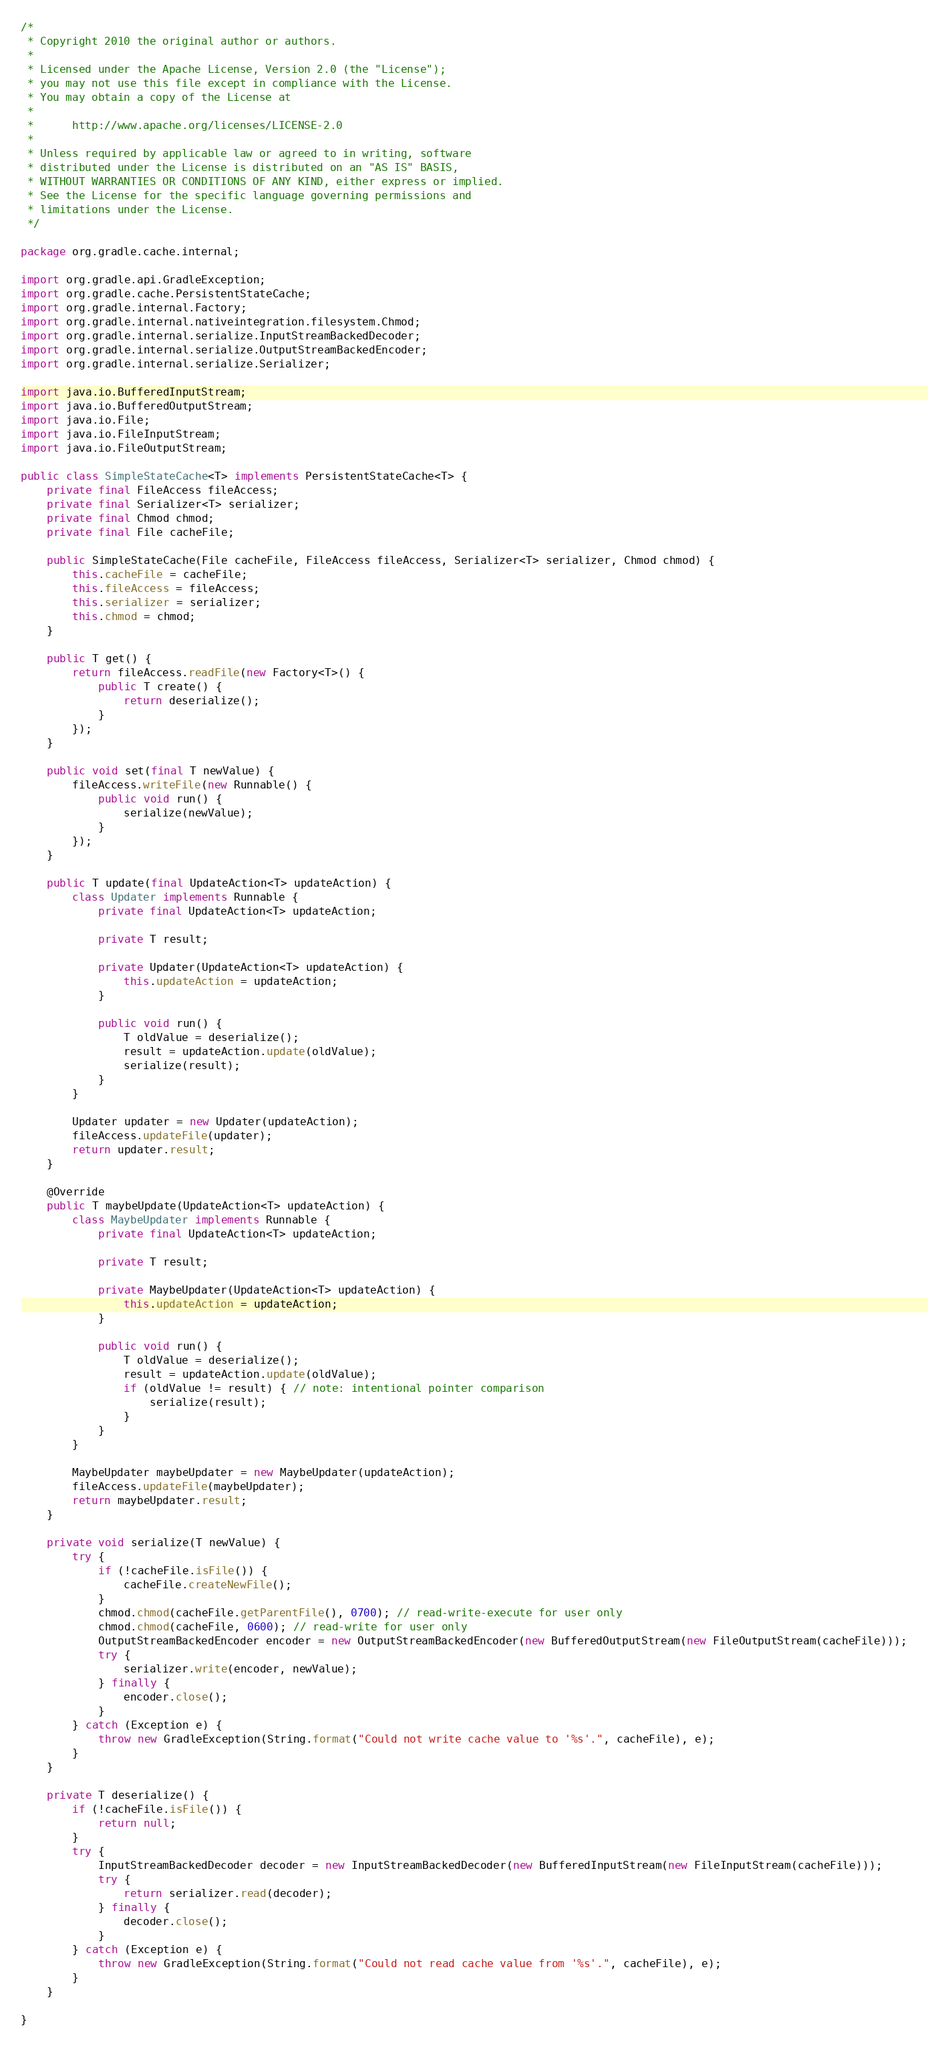<code> <loc_0><loc_0><loc_500><loc_500><_Java_>/*
 * Copyright 2010 the original author or authors.
 *
 * Licensed under the Apache License, Version 2.0 (the "License");
 * you may not use this file except in compliance with the License.
 * You may obtain a copy of the License at
 *
 *      http://www.apache.org/licenses/LICENSE-2.0
 *
 * Unless required by applicable law or agreed to in writing, software
 * distributed under the License is distributed on an "AS IS" BASIS,
 * WITHOUT WARRANTIES OR CONDITIONS OF ANY KIND, either express or implied.
 * See the License for the specific language governing permissions and
 * limitations under the License.
 */

package org.gradle.cache.internal;

import org.gradle.api.GradleException;
import org.gradle.cache.PersistentStateCache;
import org.gradle.internal.Factory;
import org.gradle.internal.nativeintegration.filesystem.Chmod;
import org.gradle.internal.serialize.InputStreamBackedDecoder;
import org.gradle.internal.serialize.OutputStreamBackedEncoder;
import org.gradle.internal.serialize.Serializer;

import java.io.BufferedInputStream;
import java.io.BufferedOutputStream;
import java.io.File;
import java.io.FileInputStream;
import java.io.FileOutputStream;

public class SimpleStateCache<T> implements PersistentStateCache<T> {
    private final FileAccess fileAccess;
    private final Serializer<T> serializer;
    private final Chmod chmod;
    private final File cacheFile;

    public SimpleStateCache(File cacheFile, FileAccess fileAccess, Serializer<T> serializer, Chmod chmod) {
        this.cacheFile = cacheFile;
        this.fileAccess = fileAccess;
        this.serializer = serializer;
        this.chmod = chmod;
    }

    public T get() {
        return fileAccess.readFile(new Factory<T>() {
            public T create() {
                return deserialize();
            }
        });
    }

    public void set(final T newValue) {
        fileAccess.writeFile(new Runnable() {
            public void run() {
                serialize(newValue);
            }
        });
    }

    public T update(final UpdateAction<T> updateAction) {
        class Updater implements Runnable {
            private final UpdateAction<T> updateAction;

            private T result;

            private Updater(UpdateAction<T> updateAction) {
                this.updateAction = updateAction;
            }

            public void run() {
                T oldValue = deserialize();
                result = updateAction.update(oldValue);
                serialize(result);
            }
        }

        Updater updater = new Updater(updateAction);
        fileAccess.updateFile(updater);
        return updater.result;
    }

    @Override
    public T maybeUpdate(UpdateAction<T> updateAction) {
        class MaybeUpdater implements Runnable {
            private final UpdateAction<T> updateAction;

            private T result;

            private MaybeUpdater(UpdateAction<T> updateAction) {
                this.updateAction = updateAction;
            }

            public void run() {
                T oldValue = deserialize();
                result = updateAction.update(oldValue);
                if (oldValue != result) { // note: intentional pointer comparison
                    serialize(result);
                }
            }
        }

        MaybeUpdater maybeUpdater = new MaybeUpdater(updateAction);
        fileAccess.updateFile(maybeUpdater);
        return maybeUpdater.result;
    }

    private void serialize(T newValue) {
        try {
            if (!cacheFile.isFile()) {
                cacheFile.createNewFile();
            }
            chmod.chmod(cacheFile.getParentFile(), 0700); // read-write-execute for user only
            chmod.chmod(cacheFile, 0600); // read-write for user only
            OutputStreamBackedEncoder encoder = new OutputStreamBackedEncoder(new BufferedOutputStream(new FileOutputStream(cacheFile)));
            try {
                serializer.write(encoder, newValue);
            } finally {
                encoder.close();
            }
        } catch (Exception e) {
            throw new GradleException(String.format("Could not write cache value to '%s'.", cacheFile), e);
        }
    }

    private T deserialize() {
        if (!cacheFile.isFile()) {
            return null;
        }
        try {
            InputStreamBackedDecoder decoder = new InputStreamBackedDecoder(new BufferedInputStream(new FileInputStream(cacheFile)));
            try {
                return serializer.read(decoder);
            } finally {
                decoder.close();
            }
        } catch (Exception e) {
            throw new GradleException(String.format("Could not read cache value from '%s'.", cacheFile), e);
        }
    }

}
</code> 